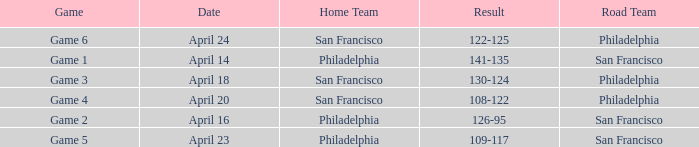Which game had Philadelphia as its home team and was played on April 23? Game 5. 